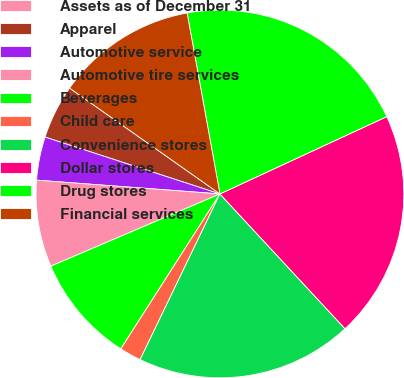Convert chart to OTSL. <chart><loc_0><loc_0><loc_500><loc_500><pie_chart><fcel>Assets as of December 31<fcel>Apparel<fcel>Automotive service<fcel>Automotive tire services<fcel>Beverages<fcel>Child care<fcel>Convenience stores<fcel>Dollar stores<fcel>Drug stores<fcel>Financial services<nl><fcel>0.0%<fcel>4.76%<fcel>3.81%<fcel>7.62%<fcel>9.52%<fcel>1.91%<fcel>19.05%<fcel>20.0%<fcel>20.95%<fcel>12.38%<nl></chart> 